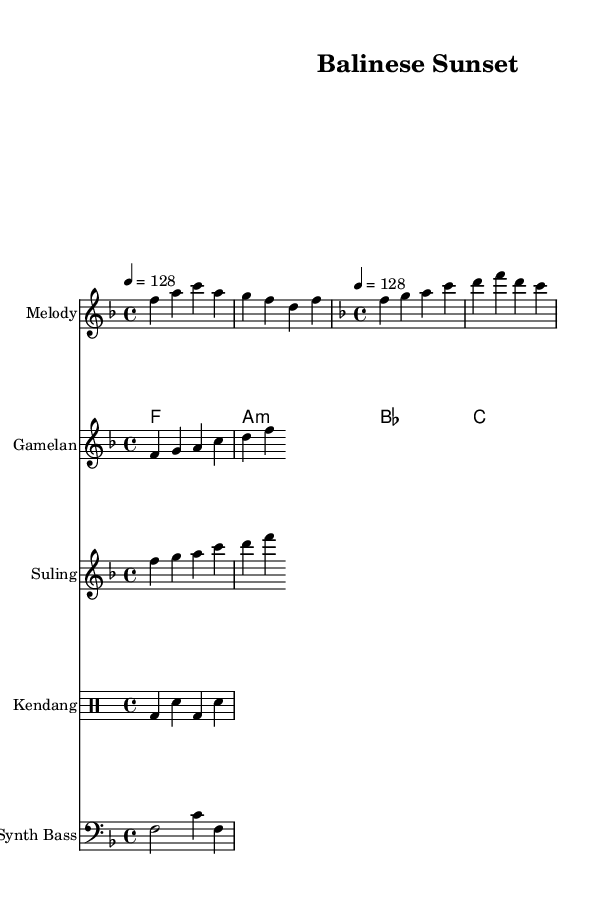What is the key signature of this music? The key signature is F major, which has one flat (B flat). This can be identified by looking at the key signature located at the beginning of the staff, which indicates the notes that will be flattened throughout the piece.
Answer: F major What is the time signature of this music? The time signature is 4/4, which means there are four beats in each measure. This is indicated at the beginning of the sheet music, to the right of the key signature.
Answer: 4/4 What is the tempo marking of the music? The tempo marking is 128 beats per minute, specified in the sheet music with "4 = 128." This indicates the speed at which the piece should be performed.
Answer: 128 How many instruments are featured in the score? There are five instruments featured in the score: Melody, Gamelan, Suling, Kendang, and Synth Bass. Each instrument is labeled at the beginning of its respective staff. Counting the labeled staffs gives the total number.
Answer: Five What are the two sections of the melody called? The two sections of the melody are the "Verse" and "Drop." These sections are labeled in the score indicating the different parts of the composition based on their melodic themes.
Answer: Verse and Drop Which traditional Indonesian instrument is included in the score? The Gamelan is included as a traditional Indonesian instrument, as seen written at the start of its staff. The Gamelan ensemble typically features various percussive instruments native to Indonesia.
Answer: Gamelan What is the rhythmic pattern for the Kendang? The rhythmic pattern for the Kendang is a combination of bass and snare hits, which is indicated by the sequences of notes laid out in the drum staff. The pattern consists of bass drums and snare in alternating order.
Answer: Bass and snare pattern 